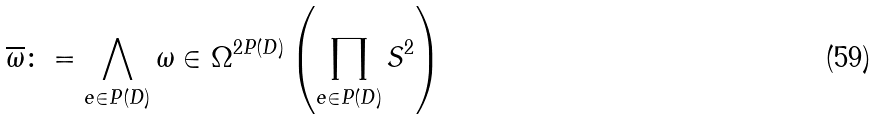Convert formula to latex. <formula><loc_0><loc_0><loc_500><loc_500>\overline { \omega } \colon = \bigwedge _ { e \in P ( D ) } \omega \in \Omega ^ { 2 P ( D ) } \left ( \prod _ { e \in P ( D ) } { S } ^ { 2 } \right )</formula> 